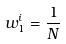Convert formula to latex. <formula><loc_0><loc_0><loc_500><loc_500>w _ { 1 } ^ { i } = \frac { 1 } { N }</formula> 